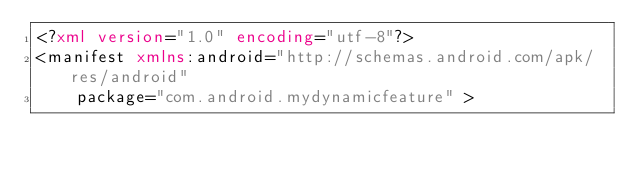<code> <loc_0><loc_0><loc_500><loc_500><_XML_><?xml version="1.0" encoding="utf-8"?>
<manifest xmlns:android="http://schemas.android.com/apk/res/android"
    package="com.android.mydynamicfeature" >
</code> 